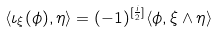<formula> <loc_0><loc_0><loc_500><loc_500>\langle \iota _ { \xi } ( \phi ) , \eta \rangle = ( - 1 ) ^ { [ { \frac { i } { 2 } } ] } \langle \phi , \xi \wedge \eta \rangle</formula> 